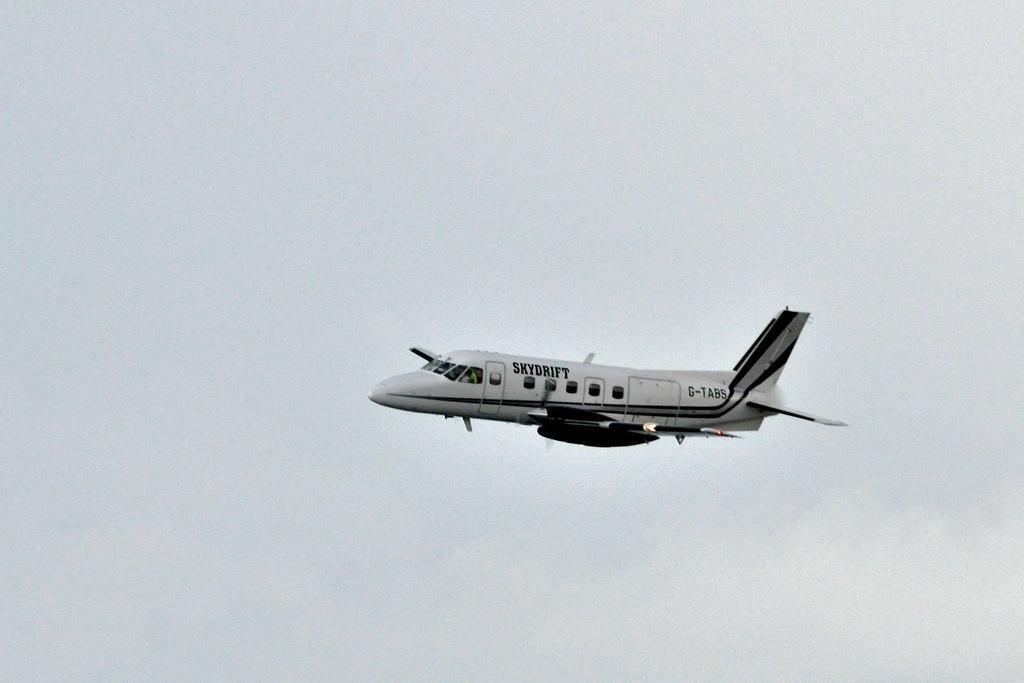Could you give a brief overview of what you see in this image? In this picture I can see an aeroplane. It is white in color and I can see cloudy sky. 